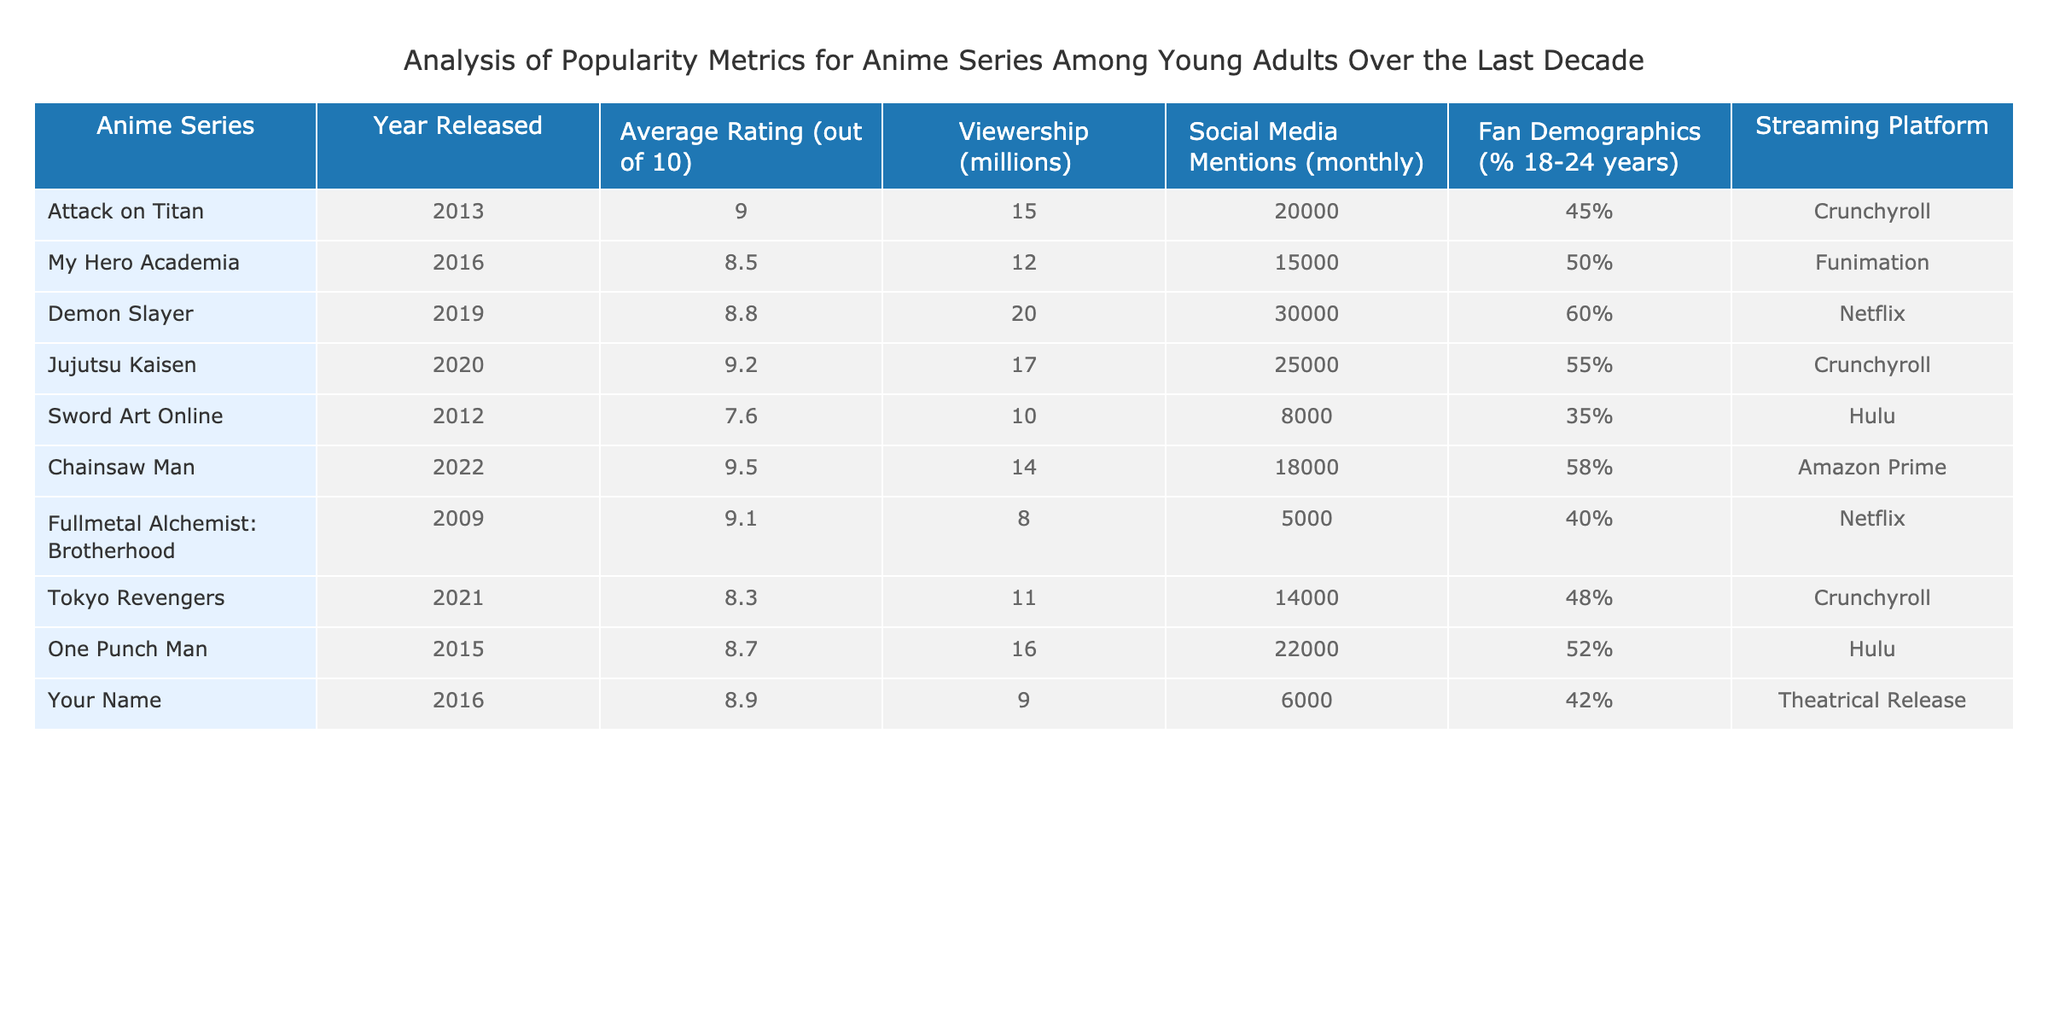What is the average rating of the anime series released in 2016? The series released in 2016 are My Hero Academia and Your Name. Their ratings are 8.5 and 8.9, respectively. Summing these ratings gives 8.5 + 8.9 = 17.4. Now, divide this sum by the number of series, which is 2. Thus, the average rating is 17.4 / 2 = 8.7.
Answer: 8.7 Which anime series had the highest viewership? Looking at the viewership column, Demon Slayer has the highest viewership with 20 million.
Answer: Demon Slayer How many anime series have an average rating of 9.0 or higher? The anime series with an average rating of 9.0 or higher are Attack on Titan (9.0), Jujutsu Kaisen (9.2), Chainsaw Man (9.5), and Fullmetal Alchemist: Brotherhood (9.1), totaling 4 series.
Answer: 4 Is there any anime series released before 2015 that has a fan demographic of over 50% aged 18-24 years? Checking the demographic percentages for series released before 2015, Attack on Titan (45%) and Sword Art Online (35%) both do not exceed 50%. Therefore, the answer is no.
Answer: No What is the total social media mentions for all anime series released in 2021? The only series released in 2021 is Tokyo Revengers, which has 14,000 social media mentions. Since there is only one series, the total is simply 14,000.
Answer: 14,000 Which streaming platform has the most anime series listed in this table? The series on Crunchyroll are Attack on Titan, Jujutsu Kaisen, and Tokyo Revengers, which makes a total of 3 series. Funimation has 1, Netflix has 2, Hulu has 2, and Amazon Prime has 1, showing that Crunchyroll has the most series.
Answer: Crunchyroll What is the difference in viewership between One Punch Man and Chainsaw Man? One Punch Man has a viewership of 16 million, and Chainsaw Man has a viewership of 14 million. To find the difference, subtract Chainsaw Man's viewership from One Punch Man's viewership: 16 - 14 = 2 million.
Answer: 2 million Are there any anime series with both a rating above 9.0 and female fan demographics above 50%? The series Jujutsu Kaisen has a rating of 9.2 and female fan demographics at 55%, meeting both criteria. Therefore, the answer is yes.
Answer: Yes 